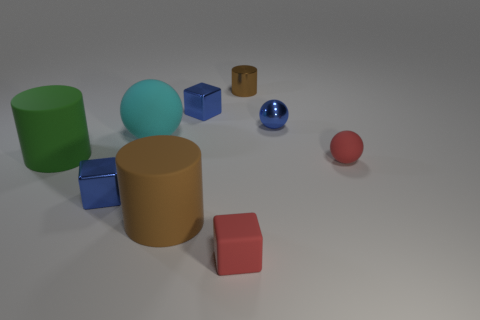Are there any repeating colors among the objects? Indeed, the color blue is repeated across three objects: two small cubes and one small sphere, each varying slightly in shade and saturation.  What do you think the purpose of arranging these objects might be? The arrangement of objects might serve educational purposes, such as teaching about shapes, colors, and materials, or it could be a simple artistic composition designed to explore geometry and spatial relationships. 